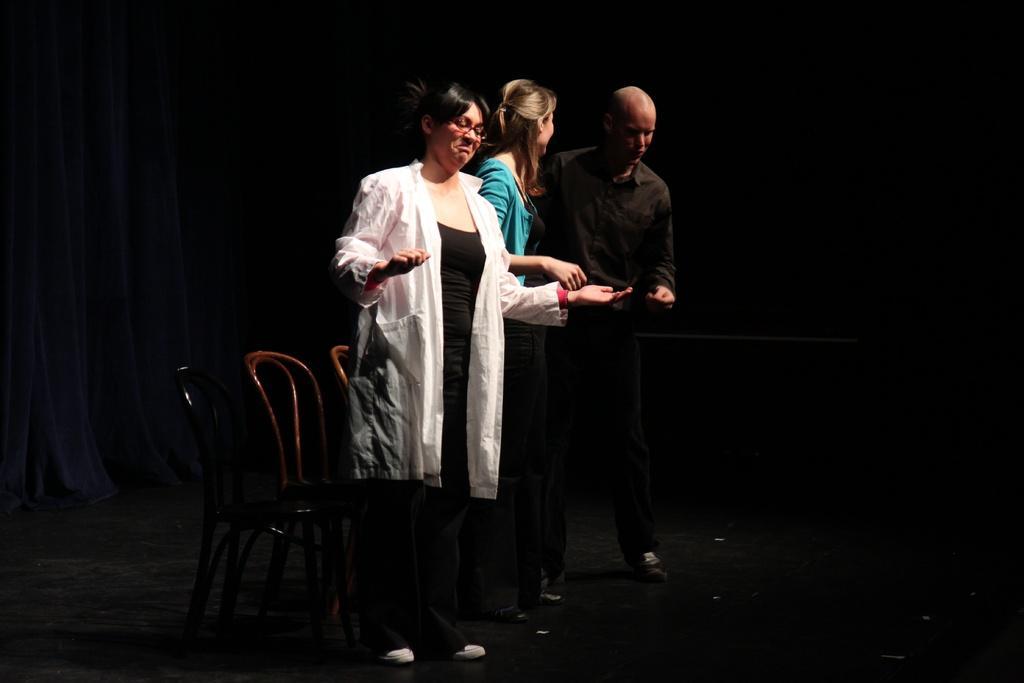Describe this image in one or two sentences. In this image we can see some people standing on the stage. We can also see some chairs beside them. On the backside we can see a curtain. 